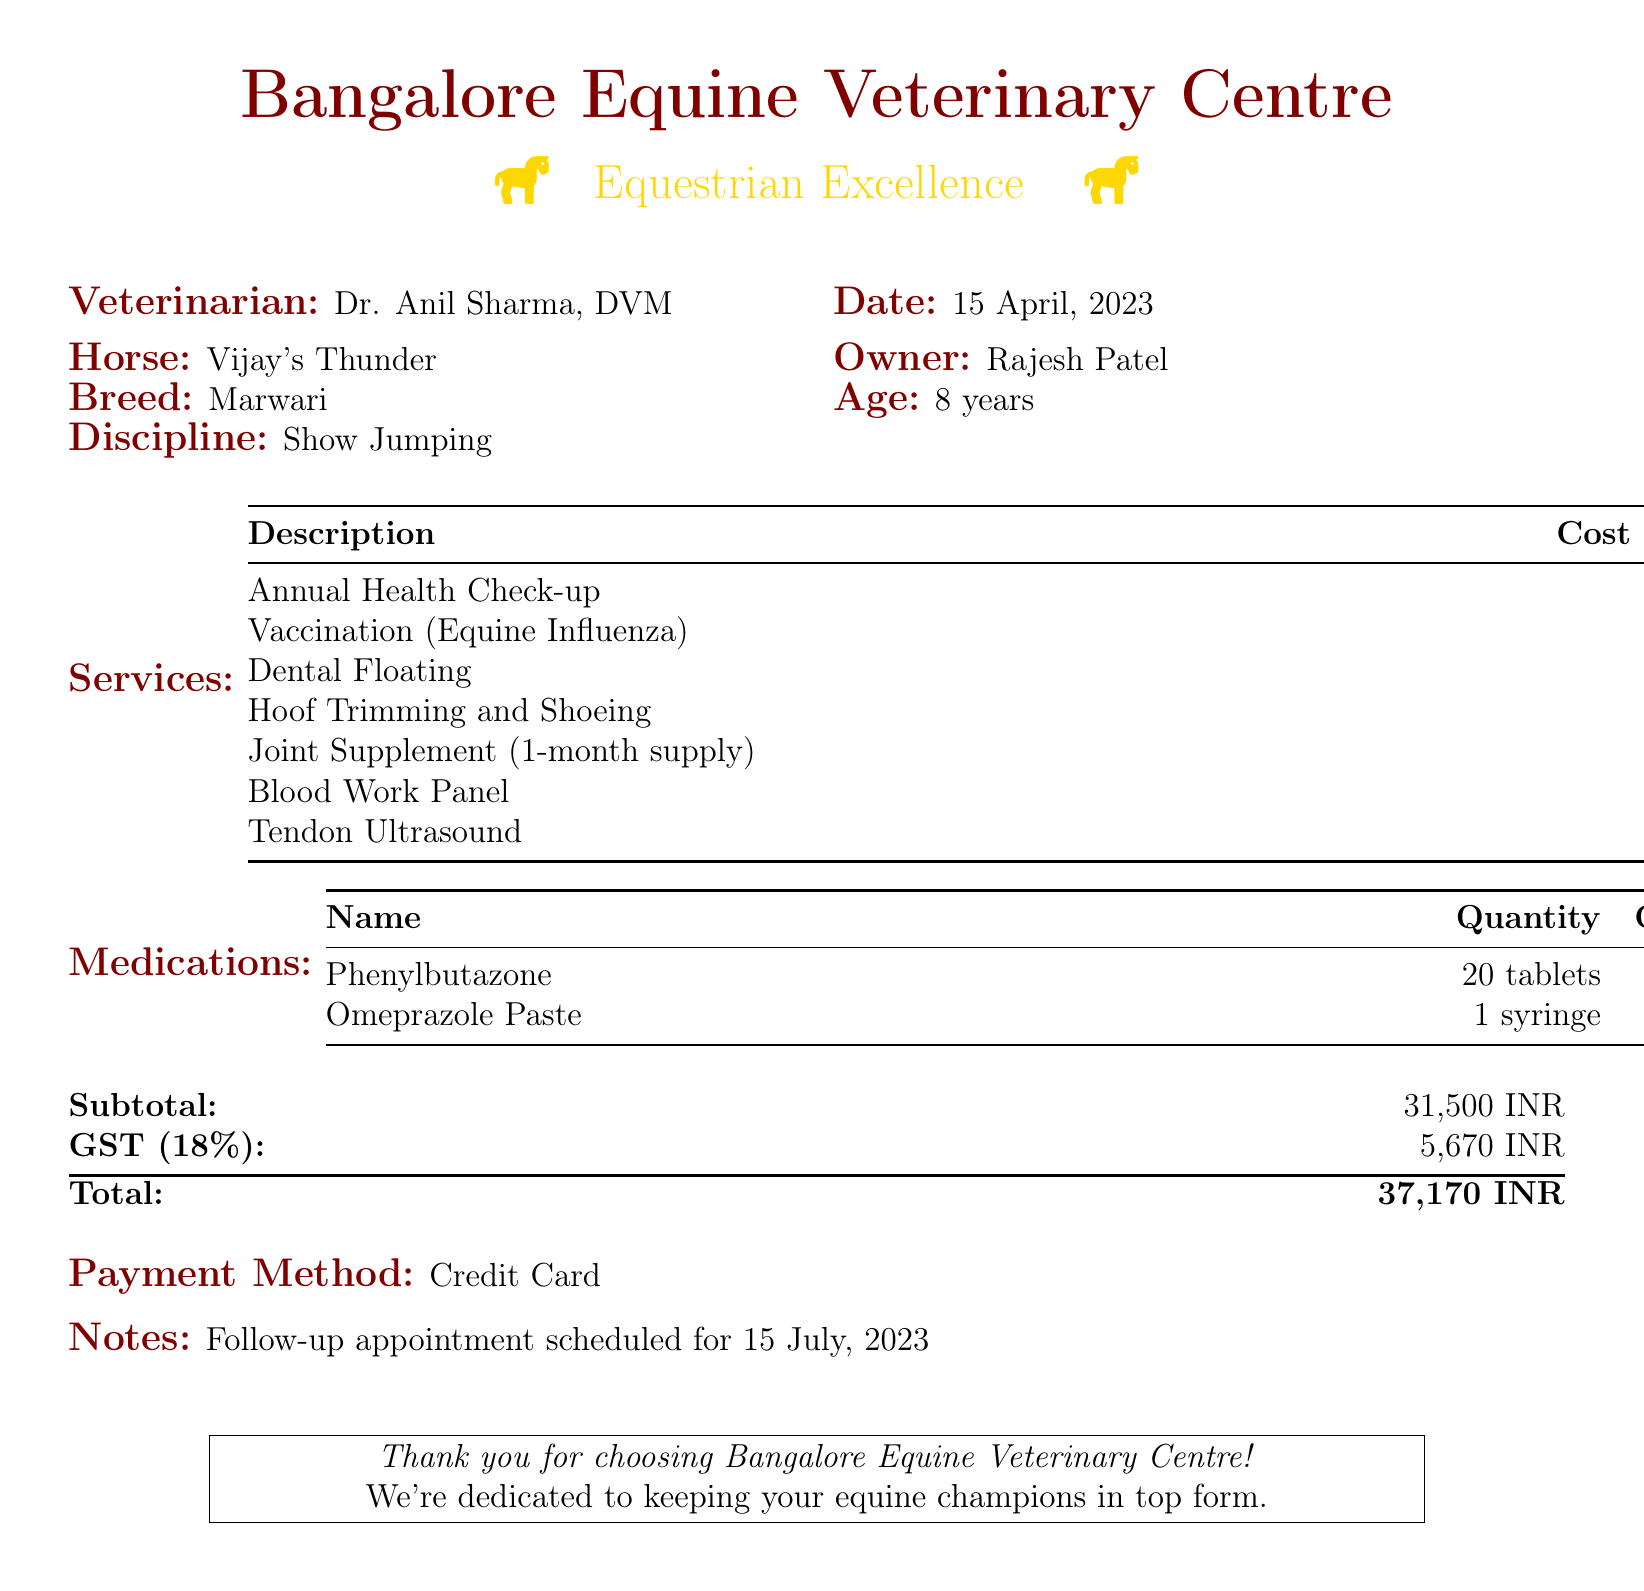What is the name of the veterinarian? The veterinarian's name is provided in the document under the Veterinarian section.
Answer: Dr. Anil Sharma What is the age of the horse? The age of the horse is specified in the document under the horse details.
Answer: 8 years What is the cost of the Annual Health Check-up? The cost for the Annual Health Check-up is listed in the Services section of the document.
Answer: 5,000 What is the GST amount calculated? The GST amount is detailed in the financial summary at the end of the document.
Answer: 5,670 What medication is provided in a syringe? The document lists the medications, and one is specified as being in a syringe.
Answer: Omeprazole Paste What is the total amount due? The total amount is presented in the financial summary as the final total to be paid.
Answer: 37,170 INR What type of payment method was used? The payment method is indicated at the end of the document.
Answer: Credit Card When is the follow-up appointment scheduled? The follow-up appointment date is mentioned in the notes section of the document.
Answer: 15 July, 2023 How many tablets of Phenylbutazone were prescribed? The quantity of Phenylbutazone is specified in the medications table.
Answer: 20 tablets 